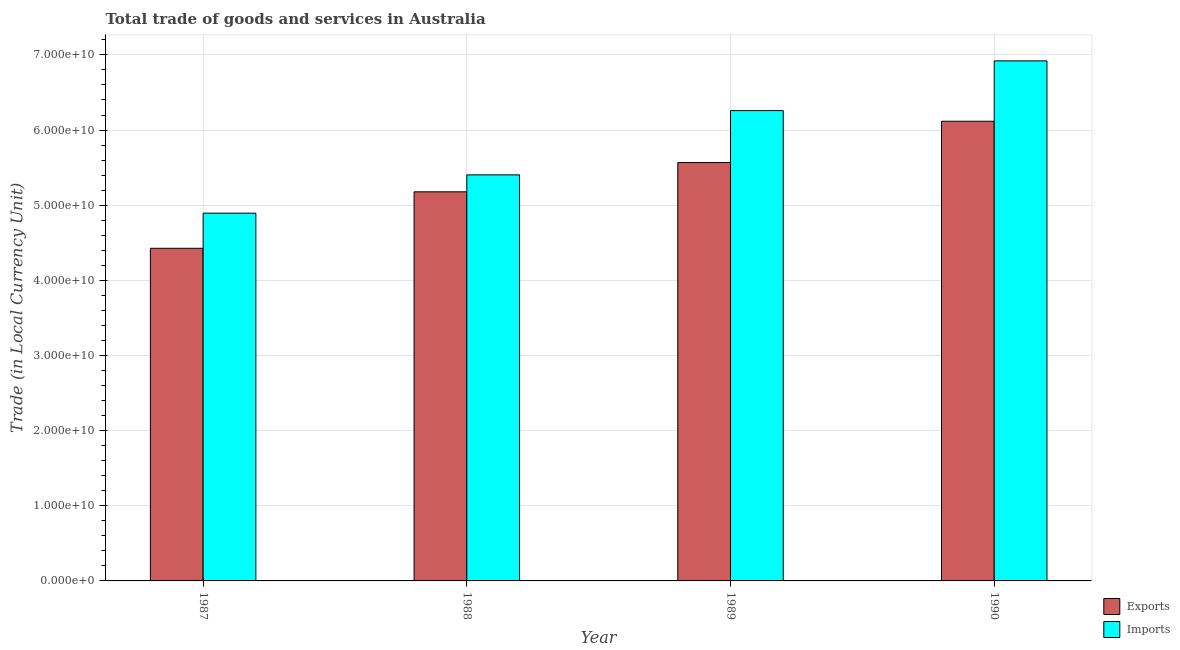How many different coloured bars are there?
Your response must be concise. 2. How many groups of bars are there?
Your answer should be very brief. 4. Are the number of bars per tick equal to the number of legend labels?
Provide a succinct answer. Yes. Are the number of bars on each tick of the X-axis equal?
Your answer should be compact. Yes. How many bars are there on the 1st tick from the right?
Provide a short and direct response. 2. What is the label of the 3rd group of bars from the left?
Ensure brevity in your answer.  1989. In how many cases, is the number of bars for a given year not equal to the number of legend labels?
Make the answer very short. 0. What is the export of goods and services in 1989?
Keep it short and to the point. 5.57e+1. Across all years, what is the maximum export of goods and services?
Offer a terse response. 6.12e+1. Across all years, what is the minimum imports of goods and services?
Your response must be concise. 4.89e+1. In which year was the export of goods and services maximum?
Offer a terse response. 1990. In which year was the imports of goods and services minimum?
Give a very brief answer. 1987. What is the total export of goods and services in the graph?
Offer a very short reply. 2.13e+11. What is the difference between the export of goods and services in 1987 and that in 1989?
Provide a short and direct response. -1.14e+1. What is the difference between the export of goods and services in 1988 and the imports of goods and services in 1987?
Ensure brevity in your answer.  7.52e+09. What is the average export of goods and services per year?
Make the answer very short. 5.32e+1. In the year 1989, what is the difference between the imports of goods and services and export of goods and services?
Provide a succinct answer. 0. What is the ratio of the imports of goods and services in 1987 to that in 1989?
Ensure brevity in your answer.  0.78. Is the export of goods and services in 1987 less than that in 1990?
Ensure brevity in your answer.  Yes. What is the difference between the highest and the second highest imports of goods and services?
Make the answer very short. 6.62e+09. What is the difference between the highest and the lowest imports of goods and services?
Make the answer very short. 2.03e+1. Is the sum of the export of goods and services in 1988 and 1989 greater than the maximum imports of goods and services across all years?
Your response must be concise. Yes. What does the 1st bar from the left in 1990 represents?
Keep it short and to the point. Exports. What does the 2nd bar from the right in 1987 represents?
Offer a very short reply. Exports. Are all the bars in the graph horizontal?
Your answer should be compact. No. Are the values on the major ticks of Y-axis written in scientific E-notation?
Provide a succinct answer. Yes. Does the graph contain any zero values?
Your response must be concise. No. Does the graph contain grids?
Keep it short and to the point. Yes. What is the title of the graph?
Ensure brevity in your answer.  Total trade of goods and services in Australia. Does "Forest land" appear as one of the legend labels in the graph?
Offer a very short reply. No. What is the label or title of the X-axis?
Provide a succinct answer. Year. What is the label or title of the Y-axis?
Offer a very short reply. Trade (in Local Currency Unit). What is the Trade (in Local Currency Unit) in Exports in 1987?
Ensure brevity in your answer.  4.43e+1. What is the Trade (in Local Currency Unit) of Imports in 1987?
Offer a very short reply. 4.89e+1. What is the Trade (in Local Currency Unit) in Exports in 1988?
Offer a very short reply. 5.18e+1. What is the Trade (in Local Currency Unit) of Imports in 1988?
Your response must be concise. 5.40e+1. What is the Trade (in Local Currency Unit) of Exports in 1989?
Keep it short and to the point. 5.57e+1. What is the Trade (in Local Currency Unit) in Imports in 1989?
Offer a terse response. 6.26e+1. What is the Trade (in Local Currency Unit) in Exports in 1990?
Provide a short and direct response. 6.12e+1. What is the Trade (in Local Currency Unit) of Imports in 1990?
Give a very brief answer. 6.92e+1. Across all years, what is the maximum Trade (in Local Currency Unit) of Exports?
Your answer should be compact. 6.12e+1. Across all years, what is the maximum Trade (in Local Currency Unit) of Imports?
Your response must be concise. 6.92e+1. Across all years, what is the minimum Trade (in Local Currency Unit) of Exports?
Provide a short and direct response. 4.43e+1. Across all years, what is the minimum Trade (in Local Currency Unit) of Imports?
Your answer should be compact. 4.89e+1. What is the total Trade (in Local Currency Unit) in Exports in the graph?
Offer a very short reply. 2.13e+11. What is the total Trade (in Local Currency Unit) in Imports in the graph?
Give a very brief answer. 2.35e+11. What is the difference between the Trade (in Local Currency Unit) in Exports in 1987 and that in 1988?
Give a very brief answer. -7.52e+09. What is the difference between the Trade (in Local Currency Unit) in Imports in 1987 and that in 1988?
Provide a short and direct response. -5.10e+09. What is the difference between the Trade (in Local Currency Unit) of Exports in 1987 and that in 1989?
Provide a short and direct response. -1.14e+1. What is the difference between the Trade (in Local Currency Unit) in Imports in 1987 and that in 1989?
Ensure brevity in your answer.  -1.36e+1. What is the difference between the Trade (in Local Currency Unit) in Exports in 1987 and that in 1990?
Provide a short and direct response. -1.69e+1. What is the difference between the Trade (in Local Currency Unit) of Imports in 1987 and that in 1990?
Make the answer very short. -2.03e+1. What is the difference between the Trade (in Local Currency Unit) of Exports in 1988 and that in 1989?
Give a very brief answer. -3.90e+09. What is the difference between the Trade (in Local Currency Unit) in Imports in 1988 and that in 1989?
Your response must be concise. -8.55e+09. What is the difference between the Trade (in Local Currency Unit) of Exports in 1988 and that in 1990?
Ensure brevity in your answer.  -9.39e+09. What is the difference between the Trade (in Local Currency Unit) in Imports in 1988 and that in 1990?
Ensure brevity in your answer.  -1.52e+1. What is the difference between the Trade (in Local Currency Unit) of Exports in 1989 and that in 1990?
Your response must be concise. -5.50e+09. What is the difference between the Trade (in Local Currency Unit) of Imports in 1989 and that in 1990?
Provide a succinct answer. -6.62e+09. What is the difference between the Trade (in Local Currency Unit) in Exports in 1987 and the Trade (in Local Currency Unit) in Imports in 1988?
Your response must be concise. -9.77e+09. What is the difference between the Trade (in Local Currency Unit) in Exports in 1987 and the Trade (in Local Currency Unit) in Imports in 1989?
Give a very brief answer. -1.83e+1. What is the difference between the Trade (in Local Currency Unit) of Exports in 1987 and the Trade (in Local Currency Unit) of Imports in 1990?
Offer a very short reply. -2.49e+1. What is the difference between the Trade (in Local Currency Unit) of Exports in 1988 and the Trade (in Local Currency Unit) of Imports in 1989?
Ensure brevity in your answer.  -1.08e+1. What is the difference between the Trade (in Local Currency Unit) in Exports in 1988 and the Trade (in Local Currency Unit) in Imports in 1990?
Your response must be concise. -1.74e+1. What is the difference between the Trade (in Local Currency Unit) in Exports in 1989 and the Trade (in Local Currency Unit) in Imports in 1990?
Offer a very short reply. -1.35e+1. What is the average Trade (in Local Currency Unit) of Exports per year?
Make the answer very short. 5.32e+1. What is the average Trade (in Local Currency Unit) in Imports per year?
Give a very brief answer. 5.87e+1. In the year 1987, what is the difference between the Trade (in Local Currency Unit) of Exports and Trade (in Local Currency Unit) of Imports?
Give a very brief answer. -4.67e+09. In the year 1988, what is the difference between the Trade (in Local Currency Unit) in Exports and Trade (in Local Currency Unit) in Imports?
Your answer should be very brief. -2.26e+09. In the year 1989, what is the difference between the Trade (in Local Currency Unit) of Exports and Trade (in Local Currency Unit) of Imports?
Offer a terse response. -6.91e+09. In the year 1990, what is the difference between the Trade (in Local Currency Unit) in Exports and Trade (in Local Currency Unit) in Imports?
Provide a short and direct response. -8.03e+09. What is the ratio of the Trade (in Local Currency Unit) in Exports in 1987 to that in 1988?
Your response must be concise. 0.85. What is the ratio of the Trade (in Local Currency Unit) of Imports in 1987 to that in 1988?
Ensure brevity in your answer.  0.91. What is the ratio of the Trade (in Local Currency Unit) of Exports in 1987 to that in 1989?
Ensure brevity in your answer.  0.8. What is the ratio of the Trade (in Local Currency Unit) of Imports in 1987 to that in 1989?
Make the answer very short. 0.78. What is the ratio of the Trade (in Local Currency Unit) of Exports in 1987 to that in 1990?
Your response must be concise. 0.72. What is the ratio of the Trade (in Local Currency Unit) in Imports in 1987 to that in 1990?
Offer a terse response. 0.71. What is the ratio of the Trade (in Local Currency Unit) in Imports in 1988 to that in 1989?
Provide a succinct answer. 0.86. What is the ratio of the Trade (in Local Currency Unit) of Exports in 1988 to that in 1990?
Offer a very short reply. 0.85. What is the ratio of the Trade (in Local Currency Unit) of Imports in 1988 to that in 1990?
Offer a terse response. 0.78. What is the ratio of the Trade (in Local Currency Unit) in Exports in 1989 to that in 1990?
Ensure brevity in your answer.  0.91. What is the ratio of the Trade (in Local Currency Unit) in Imports in 1989 to that in 1990?
Make the answer very short. 0.9. What is the difference between the highest and the second highest Trade (in Local Currency Unit) in Exports?
Ensure brevity in your answer.  5.50e+09. What is the difference between the highest and the second highest Trade (in Local Currency Unit) in Imports?
Provide a succinct answer. 6.62e+09. What is the difference between the highest and the lowest Trade (in Local Currency Unit) of Exports?
Make the answer very short. 1.69e+1. What is the difference between the highest and the lowest Trade (in Local Currency Unit) in Imports?
Make the answer very short. 2.03e+1. 